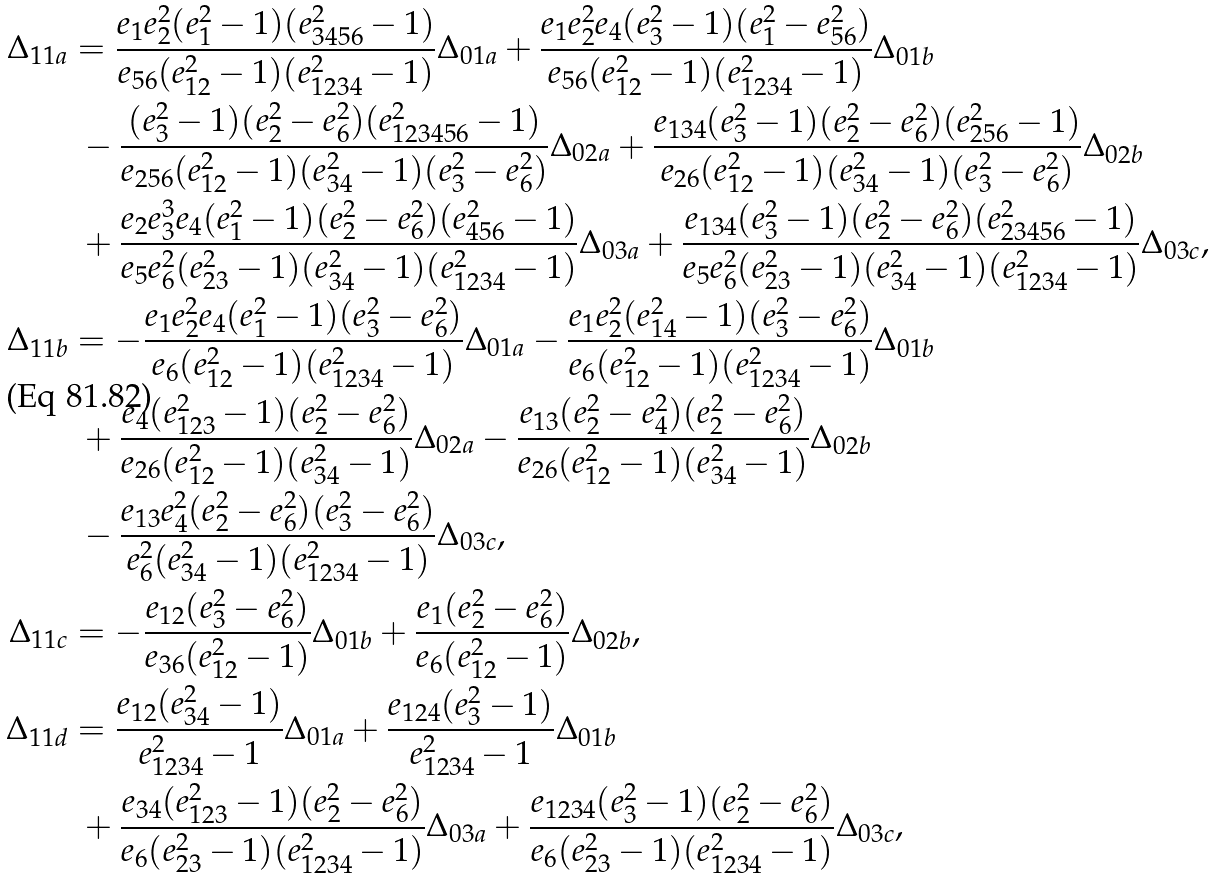<formula> <loc_0><loc_0><loc_500><loc_500>\Delta _ { 1 1 a } & = \frac { e _ { 1 } e _ { 2 } ^ { 2 } ( e _ { 1 } ^ { 2 } - 1 ) ( e _ { 3 4 5 6 } ^ { 2 } - 1 ) } { e _ { 5 6 } ( e _ { 1 2 } ^ { 2 } - 1 ) ( e _ { 1 2 3 4 } ^ { 2 } - 1 ) } \Delta _ { 0 1 a } + \frac { e _ { 1 } e _ { 2 } ^ { 2 } e _ { 4 } ( e _ { 3 } ^ { 2 } - 1 ) ( e _ { 1 } ^ { 2 } - e _ { 5 6 } ^ { 2 } ) } { e _ { 5 6 } ( e _ { 1 2 } ^ { 2 } - 1 ) ( e _ { 1 2 3 4 } ^ { 2 } - 1 ) } \Delta _ { 0 1 b } \\ & \ - \frac { ( e _ { 3 } ^ { 2 } - 1 ) ( e _ { 2 } ^ { 2 } - e _ { 6 } ^ { 2 } ) ( e _ { 1 2 3 4 5 6 } ^ { 2 } - 1 ) } { e _ { 2 5 6 } ( e _ { 1 2 } ^ { 2 } - 1 ) ( e _ { 3 4 } ^ { 2 } - 1 ) ( e _ { 3 } ^ { 2 } - e _ { 6 } ^ { 2 } ) } \Delta _ { 0 2 a } + \frac { e _ { 1 3 4 } ( e _ { 3 } ^ { 2 } - 1 ) ( e _ { 2 } ^ { 2 } - e _ { 6 } ^ { 2 } ) ( e _ { 2 5 6 } ^ { 2 } - 1 ) } { e _ { 2 6 } ( e _ { 1 2 } ^ { 2 } - 1 ) ( e _ { 3 4 } ^ { 2 } - 1 ) ( e _ { 3 } ^ { 2 } - e _ { 6 } ^ { 2 } ) } \Delta _ { 0 2 b } \\ & \ + \frac { e _ { 2 } e _ { 3 } ^ { 3 } e _ { 4 } ( e _ { 1 } ^ { 2 } - 1 ) ( e _ { 2 } ^ { 2 } - e _ { 6 } ^ { 2 } ) ( e _ { 4 5 6 } ^ { 2 } - 1 ) } { e _ { 5 } e _ { 6 } ^ { 2 } ( e _ { 2 3 } ^ { 2 } - 1 ) ( e _ { 3 4 } ^ { 2 } - 1 ) ( e _ { 1 2 3 4 } ^ { 2 } - 1 ) } \Delta _ { 0 3 a } + \frac { e _ { 1 3 4 } ( e _ { 3 } ^ { 2 } - 1 ) ( e _ { 2 } ^ { 2 } - e _ { 6 } ^ { 2 } ) ( e _ { 2 3 4 5 6 } ^ { 2 } - 1 ) } { e _ { 5 } e _ { 6 } ^ { 2 } ( e _ { 2 3 } ^ { 2 } - 1 ) ( e _ { 3 4 } ^ { 2 } - 1 ) ( e _ { 1 2 3 4 } ^ { 2 } - 1 ) } \Delta _ { 0 3 c } , \\ \Delta _ { 1 1 b } & = - \frac { e _ { 1 } e _ { 2 } ^ { 2 } e _ { 4 } ( e _ { 1 } ^ { 2 } - 1 ) ( e _ { 3 } ^ { 2 } - e _ { 6 } ^ { 2 } ) } { e _ { 6 } ( e _ { 1 2 } ^ { 2 } - 1 ) ( e _ { 1 2 3 4 } ^ { 2 } - 1 ) } \Delta _ { 0 1 a } - \frac { e _ { 1 } e _ { 2 } ^ { 2 } ( e _ { 1 4 } ^ { 2 } - 1 ) ( e _ { 3 } ^ { 2 } - e _ { 6 } ^ { 2 } ) } { e _ { 6 } ( e _ { 1 2 } ^ { 2 } - 1 ) ( e _ { 1 2 3 4 } ^ { 2 } - 1 ) } \Delta _ { 0 1 b } \\ & \ + \frac { e _ { 4 } ( e _ { 1 2 3 } ^ { 2 } - 1 ) ( e _ { 2 } ^ { 2 } - e _ { 6 } ^ { 2 } ) } { e _ { 2 6 } ( e _ { 1 2 } ^ { 2 } - 1 ) ( e _ { 3 4 } ^ { 2 } - 1 ) } \Delta _ { 0 2 a } - \frac { e _ { 1 3 } ( e _ { 2 } ^ { 2 } - e _ { 4 } ^ { 2 } ) ( e _ { 2 } ^ { 2 } - e _ { 6 } ^ { 2 } ) } { e _ { 2 6 } ( e _ { 1 2 } ^ { 2 } - 1 ) ( e _ { 3 4 } ^ { 2 } - 1 ) } \Delta _ { 0 2 b } \\ & \ - \frac { e _ { 1 3 } e _ { 4 } ^ { 2 } ( e _ { 2 } ^ { 2 } - e _ { 6 } ^ { 2 } ) ( e _ { 3 } ^ { 2 } - e _ { 6 } ^ { 2 } ) } { e _ { 6 } ^ { 2 } ( e _ { 3 4 } ^ { 2 } - 1 ) ( e _ { 1 2 3 4 } ^ { 2 } - 1 ) } \Delta _ { 0 3 c } , \\ \Delta _ { 1 1 c } & = - \frac { e _ { 1 2 } ( e _ { 3 } ^ { 2 } - e _ { 6 } ^ { 2 } ) } { e _ { 3 6 } ( e _ { 1 2 } ^ { 2 } - 1 ) } \Delta _ { 0 1 b } + \frac { e _ { 1 } ( e _ { 2 } ^ { 2 } - e _ { 6 } ^ { 2 } ) } { e _ { 6 } ( e _ { 1 2 } ^ { 2 } - 1 ) } \Delta _ { 0 2 b } , \\ \Delta _ { 1 1 d } & = \frac { e _ { 1 2 } ( e _ { 3 4 } ^ { 2 } - 1 ) } { e _ { 1 2 3 4 } ^ { 2 } - 1 } \Delta _ { 0 1 a } + \frac { e _ { 1 2 4 } ( e _ { 3 } ^ { 2 } - 1 ) } { e _ { 1 2 3 4 } ^ { 2 } - 1 } \Delta _ { 0 1 b } \\ & \ + \frac { e _ { 3 4 } ( e _ { 1 2 3 } ^ { 2 } - 1 ) ( e _ { 2 } ^ { 2 } - e _ { 6 } ^ { 2 } ) } { e _ { 6 } ( e _ { 2 3 } ^ { 2 } - 1 ) ( e _ { 1 2 3 4 } ^ { 2 } - 1 ) } \Delta _ { 0 3 a } + \frac { e _ { 1 2 3 4 } ( e _ { 3 } ^ { 2 } - 1 ) ( e _ { 2 } ^ { 2 } - e _ { 6 } ^ { 2 } ) } { e _ { 6 } ( e _ { 2 3 } ^ { 2 } - 1 ) ( e _ { 1 2 3 4 } ^ { 2 } - 1 ) } \Delta _ { 0 3 c } ,</formula> 